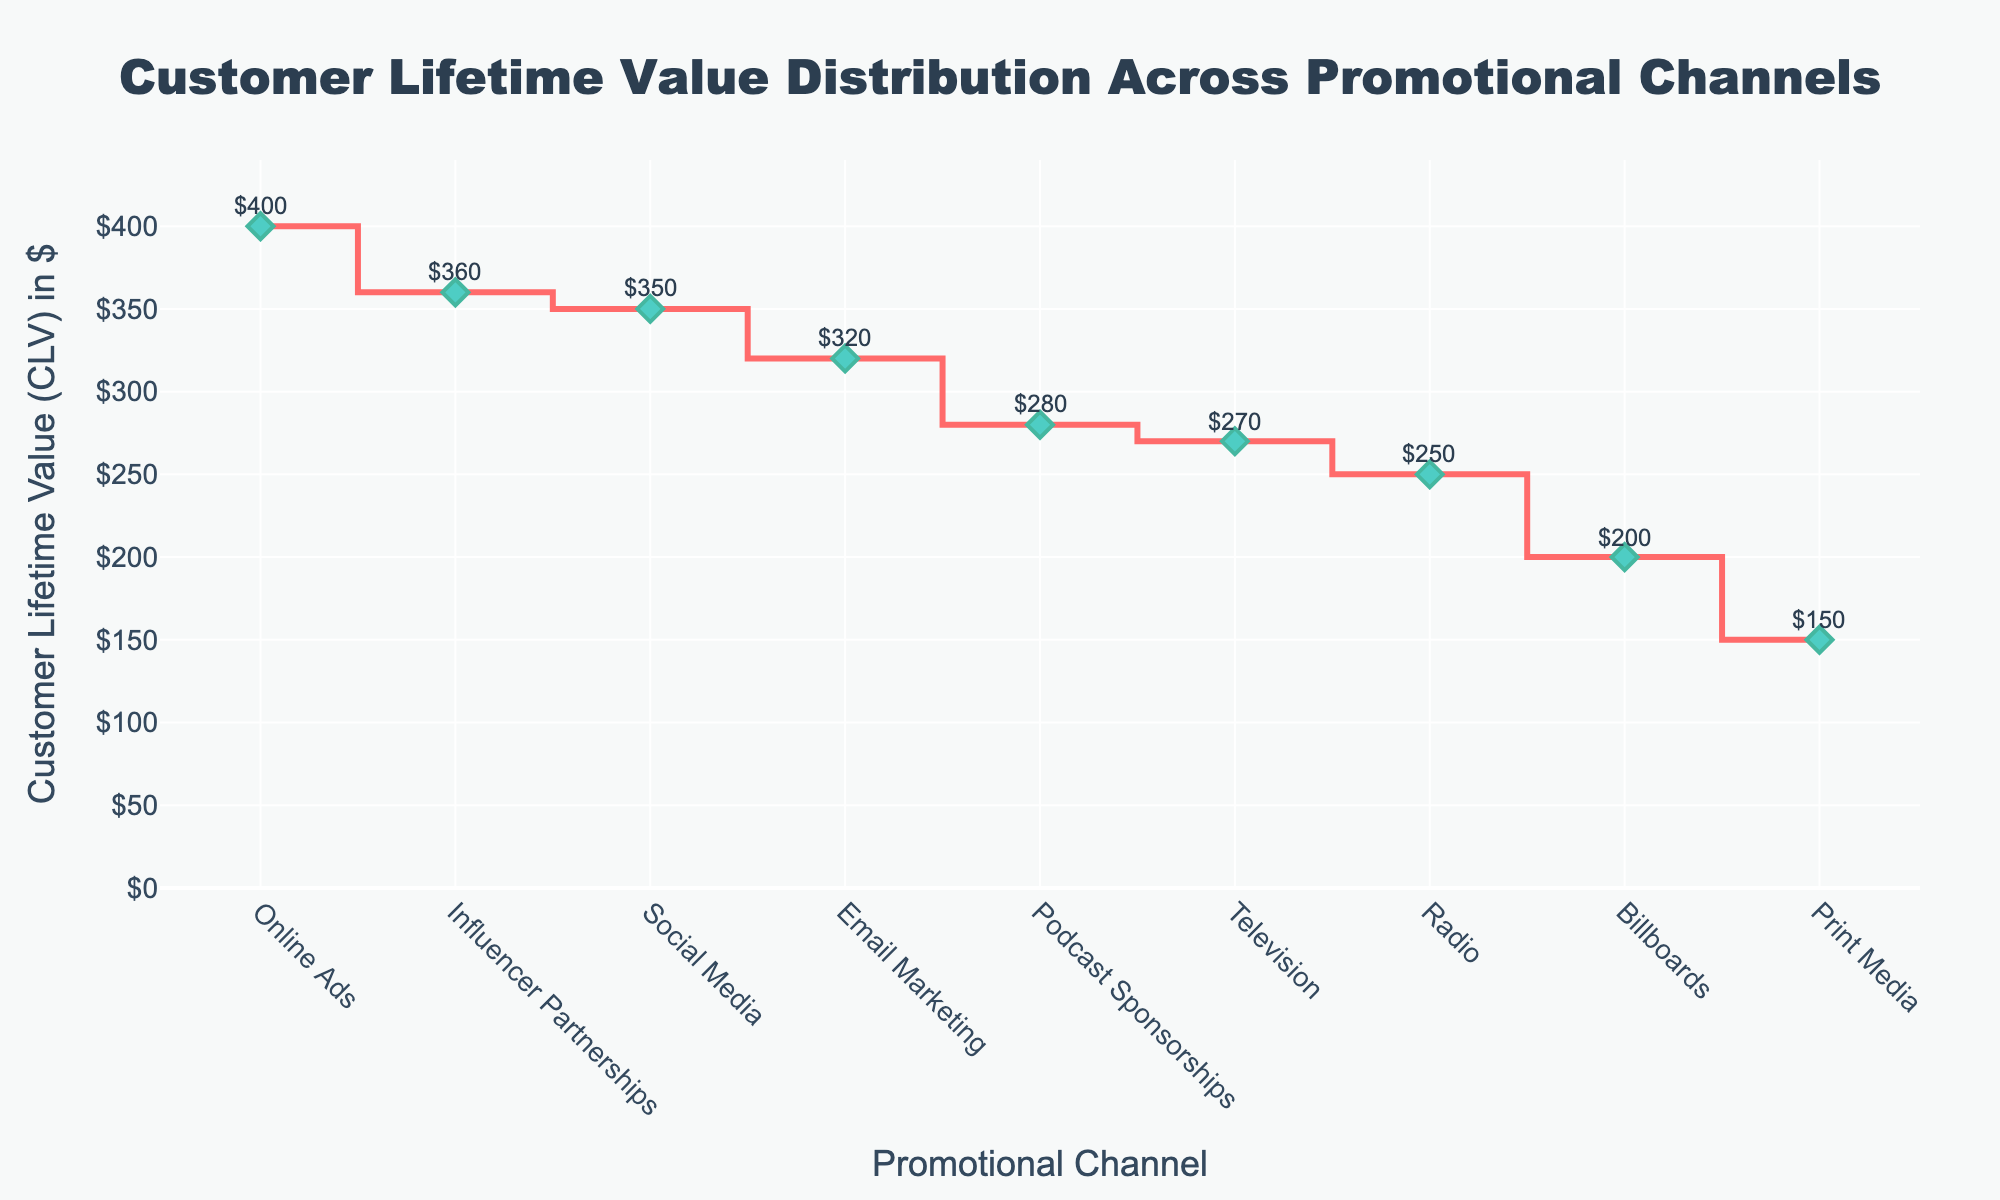What's the highest Customer Lifetime Value (CLV)? Looking at the plot, the highest CLV point can be identified. The corresponding channel is Online Ads.
Answer: $400 Which promotional channel shows the lowest CLV? By scanning the stair plot from the lowest to the highest values, we see that Print Media has the lowest CLV.
Answer: Print Media What is the difference in CLV between Influencer Partnerships and Billboards? Influencer Partnerships have a CLV of $360 and Billboards have a CLV of $200. Subtracting these gives $360 - $200
Answer: $160 Which promotional channels have a CLV greater than $300? Observing the plot, the channels with CLV greater than $300 are Social Media, Online Ads, Influencer Partnerships, and Email Marketing.
Answer: Social Media, Online Ads, Influencer Partnerships, Email Marketing What is the average CLV of Radio and Podcast Sponsorships? Radio has a CLV of $250 and Podcast Sponsorships have a CLV of $280. Adding these gives $250 + $280 = $530. Dividing by 2 gives $530/2.
Answer: $265 How many promotional channels have a CLV less than $300? By checking each channel's CLV, we see that Television, Radio, Billboards, Podcast Sponsorships, and Print Media fall below $300. There are 5 such channels.
Answer: 5 Between Email Marketing and Social Media, which has a higher CLV? Looking at the plot, Social Media has a CLV of $350 and Email Marketing has a CLV of $320. Social Media has a higher CLV.
Answer: Social Media What is the total CLV of Television, Radio, and Billboards? Summing the CLV of Television ($270), Radio ($250), and Billboards ($200) gives $270 + $250 + $200
Answer: $720 How much higher is Social Media's CLV compared to Television's? Social Media has a CLV of $350 and Television has a CLV of $270. Subtracting these gives $350 - $270
Answer: $80 